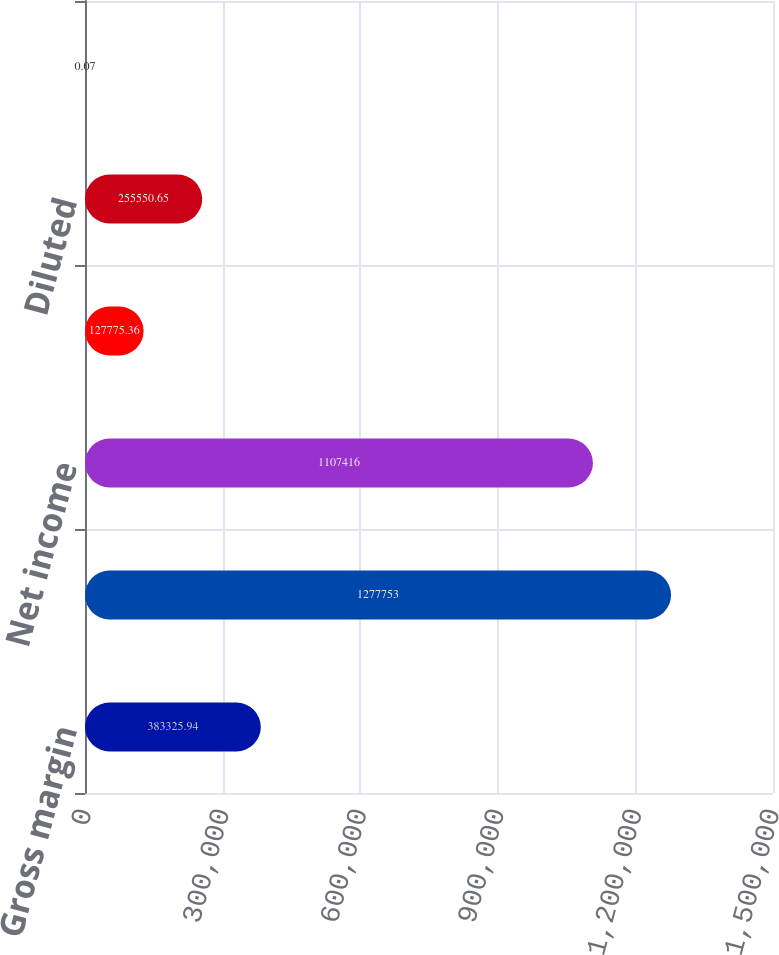Convert chart. <chart><loc_0><loc_0><loc_500><loc_500><bar_chart><fcel>Gross margin<fcel>Income before income taxes<fcel>Net income<fcel>Basic<fcel>Diluted<fcel>Cash dividends declared per<nl><fcel>383326<fcel>1.27775e+06<fcel>1.10742e+06<fcel>127775<fcel>255551<fcel>0.07<nl></chart> 